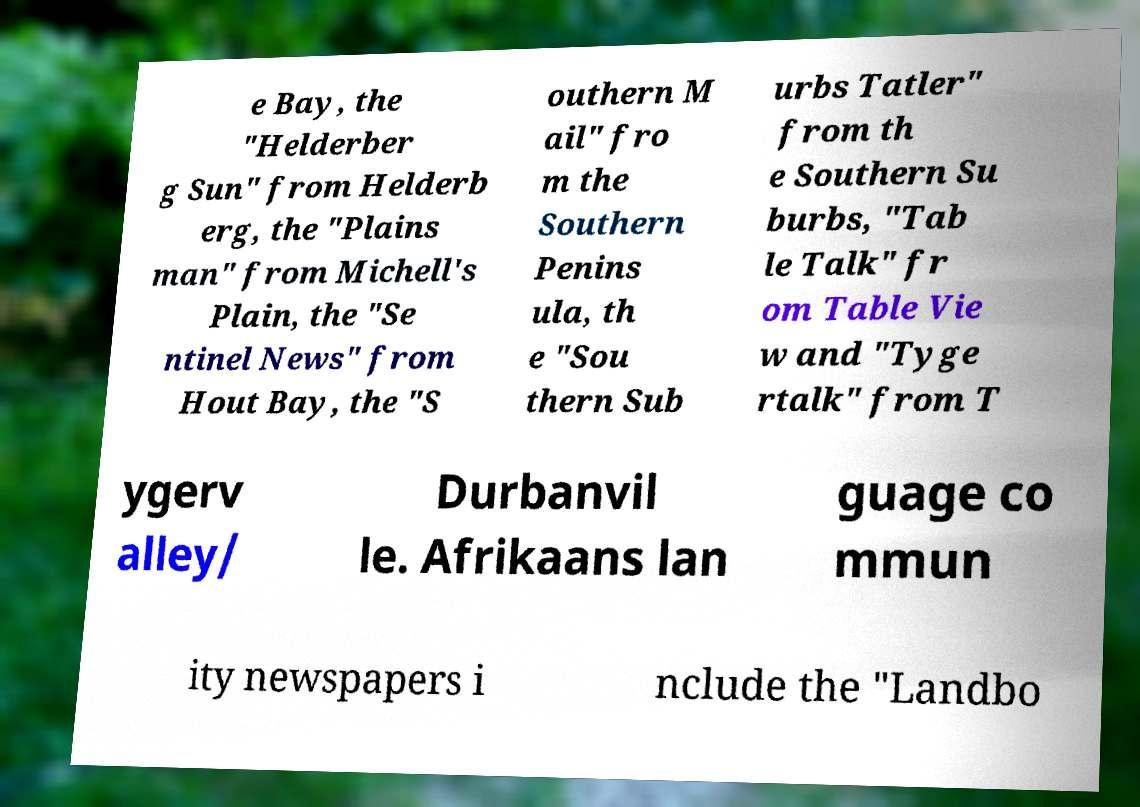Can you read and provide the text displayed in the image?This photo seems to have some interesting text. Can you extract and type it out for me? e Bay, the "Helderber g Sun" from Helderb erg, the "Plains man" from Michell's Plain, the "Se ntinel News" from Hout Bay, the "S outhern M ail" fro m the Southern Penins ula, th e "Sou thern Sub urbs Tatler" from th e Southern Su burbs, "Tab le Talk" fr om Table Vie w and "Tyge rtalk" from T ygerv alley/ Durbanvil le. Afrikaans lan guage co mmun ity newspapers i nclude the "Landbo 